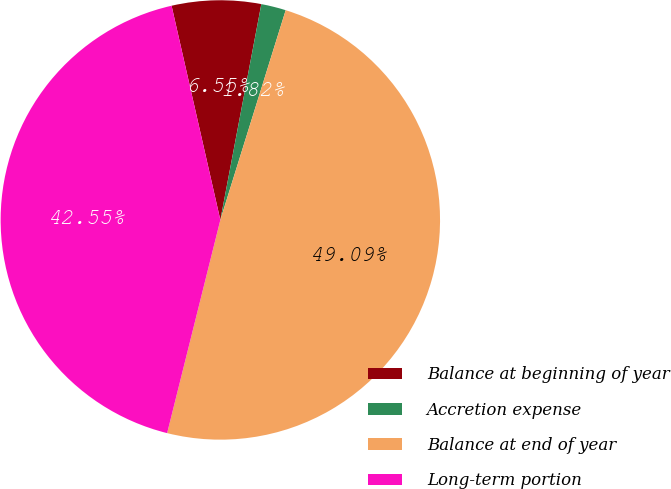Convert chart to OTSL. <chart><loc_0><loc_0><loc_500><loc_500><pie_chart><fcel>Balance at beginning of year<fcel>Accretion expense<fcel>Balance at end of year<fcel>Long-term portion<nl><fcel>6.55%<fcel>1.82%<fcel>49.09%<fcel>42.55%<nl></chart> 